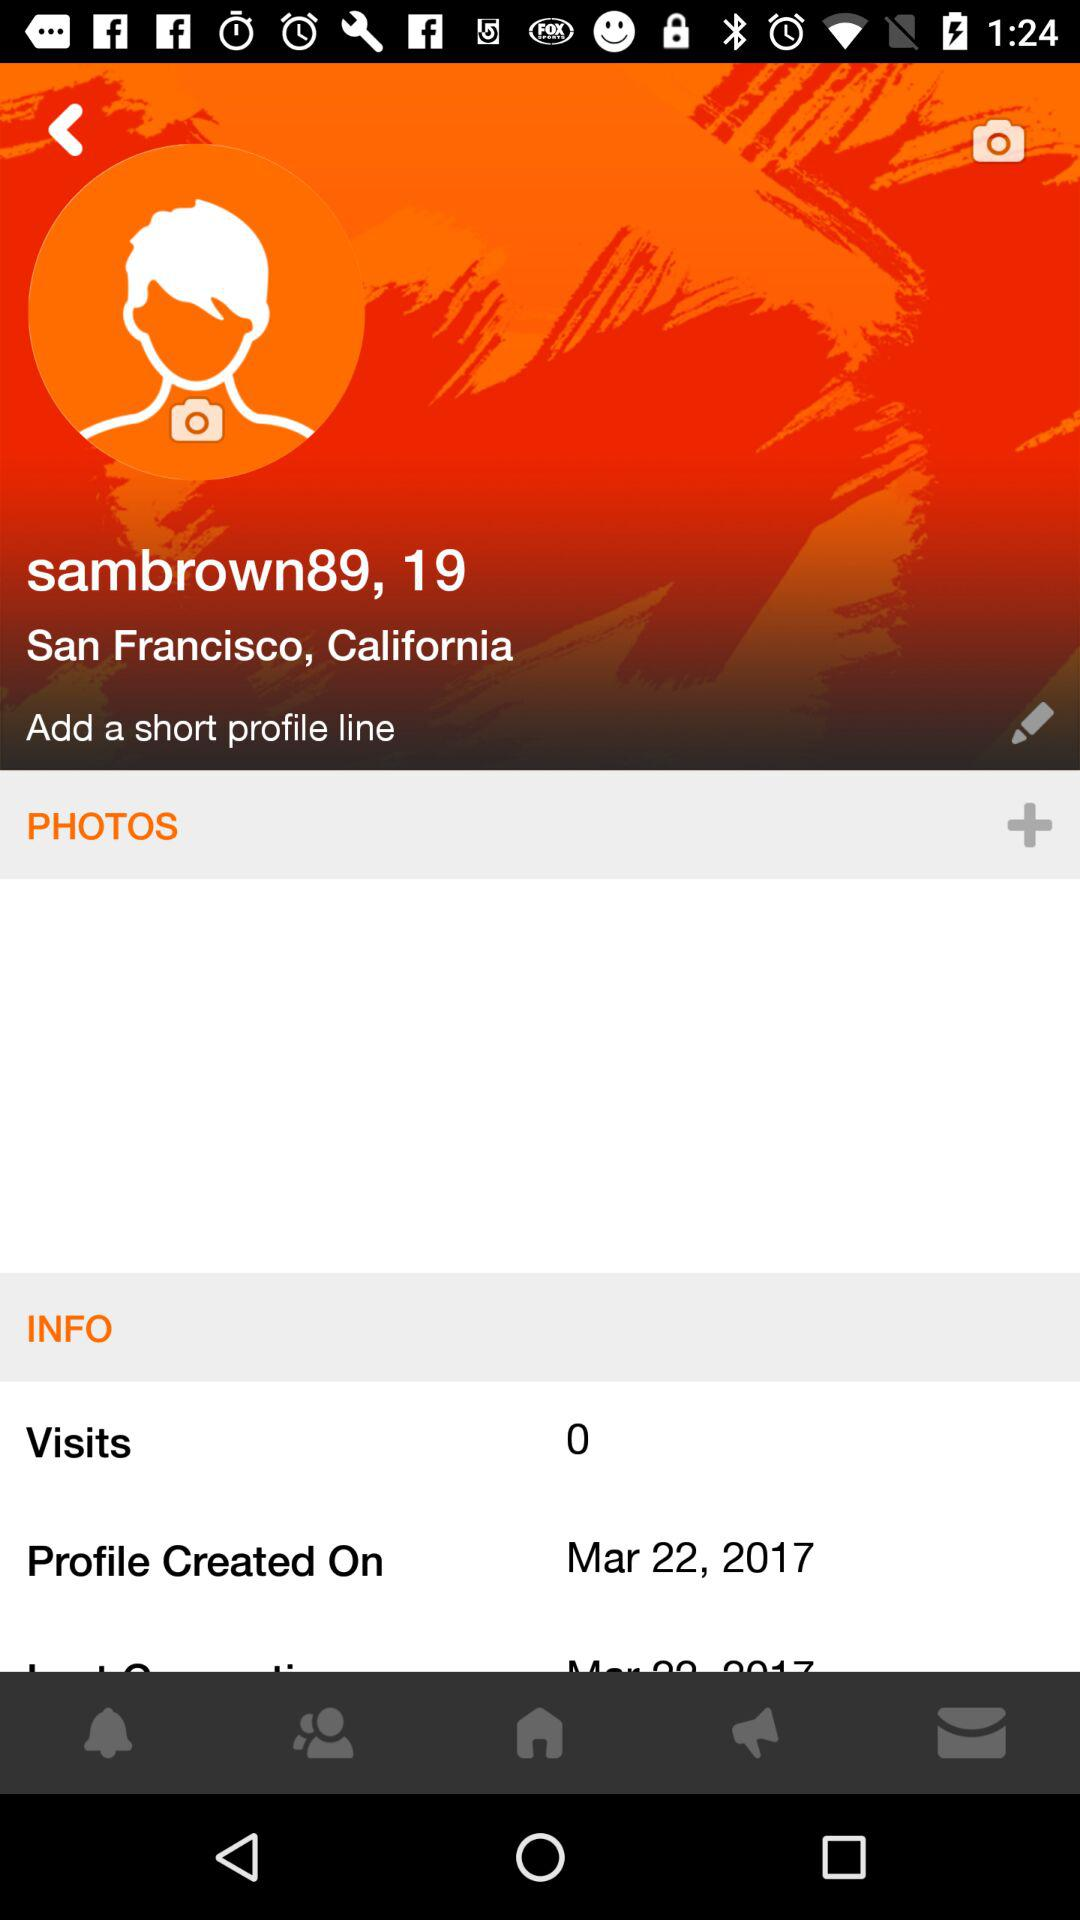When was the profile created? The profile was created on March 22, 2017. 